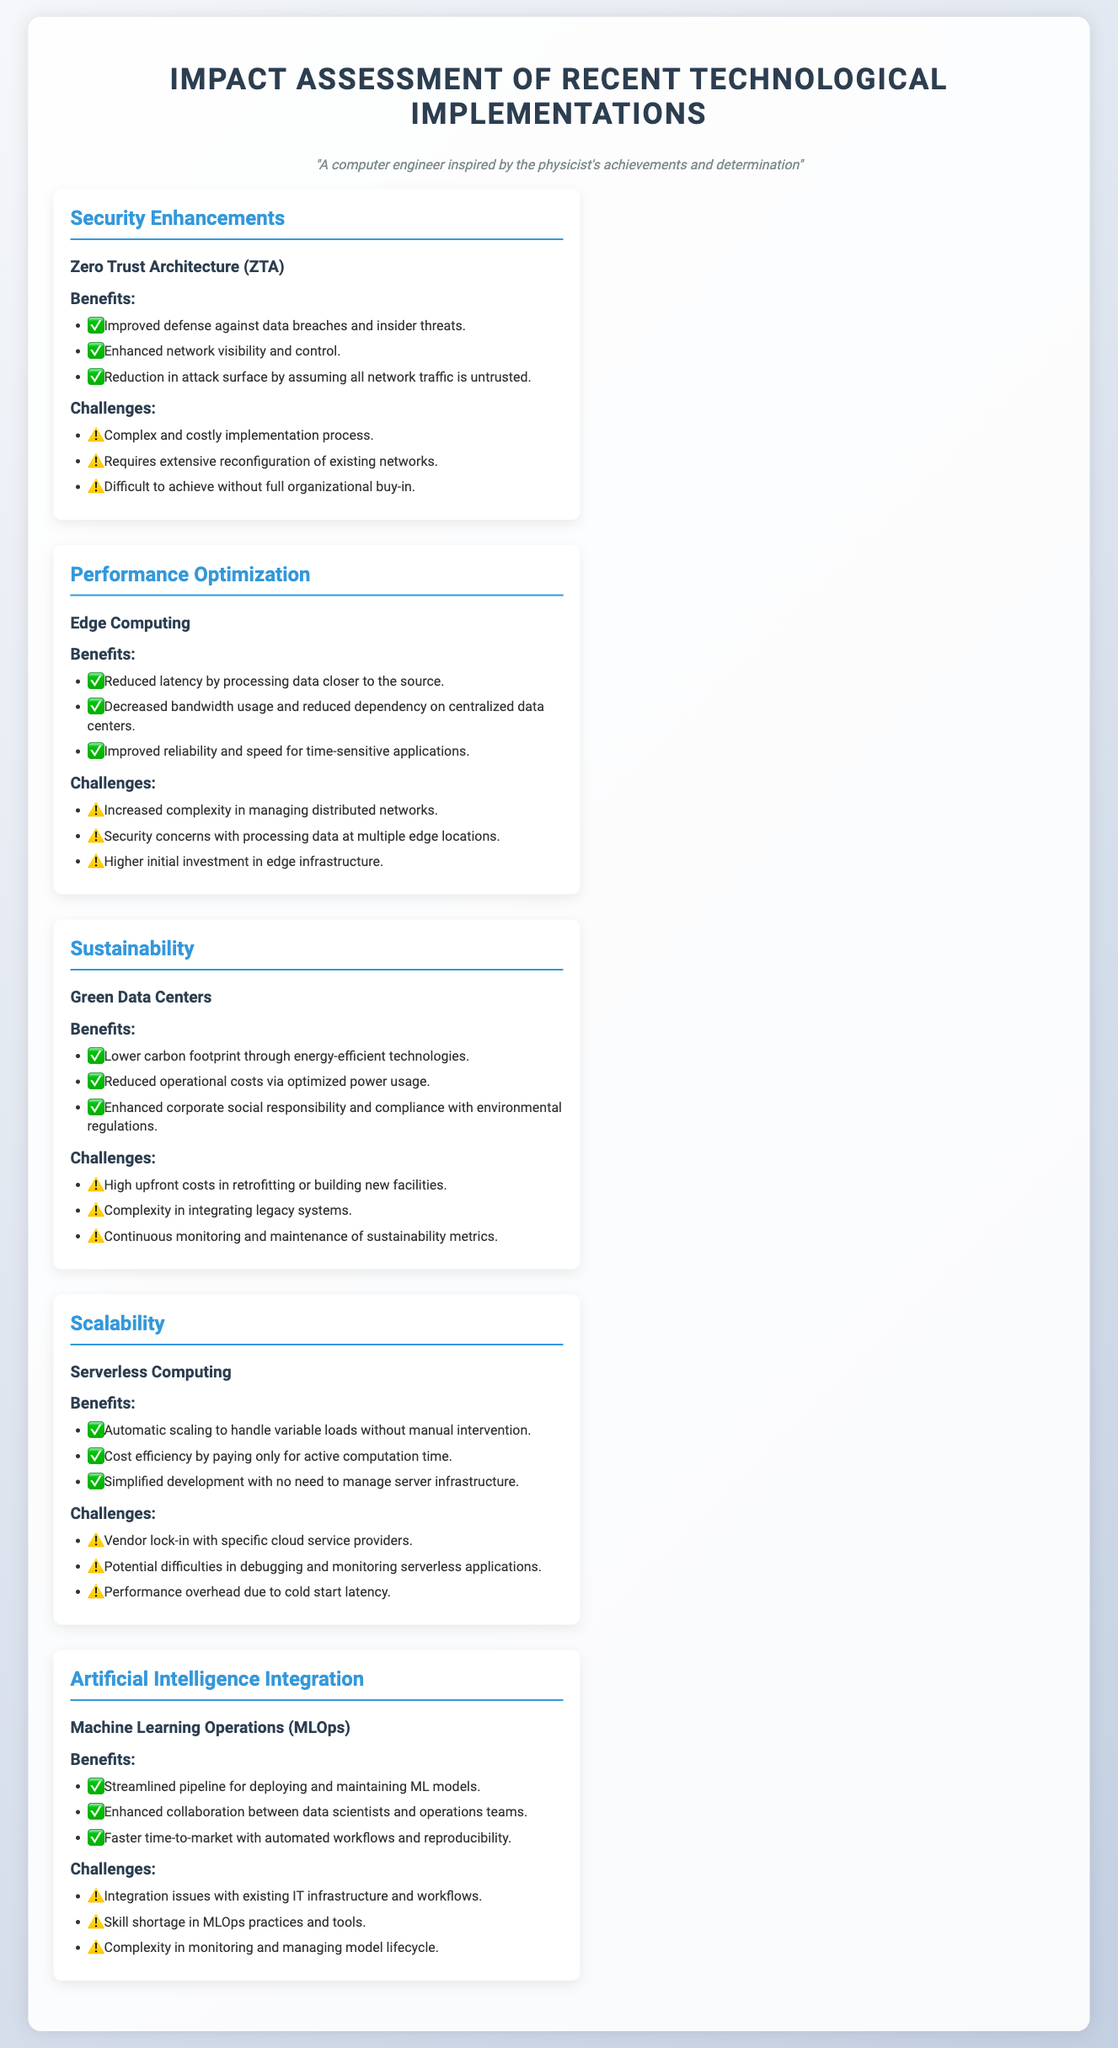What are the benefits of Zero Trust Architecture? The benefits include improved defense against data breaches and insider threats, enhanced network visibility and control, and reduction in attack surface by assuming all network traffic is untrusted.
Answer: Improved defense against data breaches and insider threats, enhanced network visibility and control, reduction in attack surface by assuming all network traffic is untrusted What is one challenge of Edge Computing? One challenge listed is increased complexity in managing distributed networks.
Answer: Increased complexity in managing distributed networks What sustainability feature is highlighted in the scorecard? The feature highlighted under sustainability is Green Data Centers.
Answer: Green Data Centers What are the benefits of Serverless Computing? The benefits include automatic scaling to handle variable loads, cost efficiency by paying only for active computation time, and simplified development with no need to manage server infrastructure.
Answer: Automatic scaling, cost efficiency, simplified development Which technological implementation is associated with MLOps? Machine Learning Operations is the implementation associated with MLOps.
Answer: Machine Learning Operations What is a significant challenge related to Machine Learning Operations? A significant challenge is the integration issues with existing IT infrastructure and workflows.
Answer: Integration issues with existing IT infrastructure and workflows How does Edge Computing improve performance? Edge Computing improves performance by reducing latency by processing data closer to the source.
Answer: Reduced latency by processing data closer to the source What is the main benefit of Green Data Centers? The main benefit is a lower carbon footprint through energy-efficient technologies.
Answer: Lower carbon footprint through energy-efficient technologies 